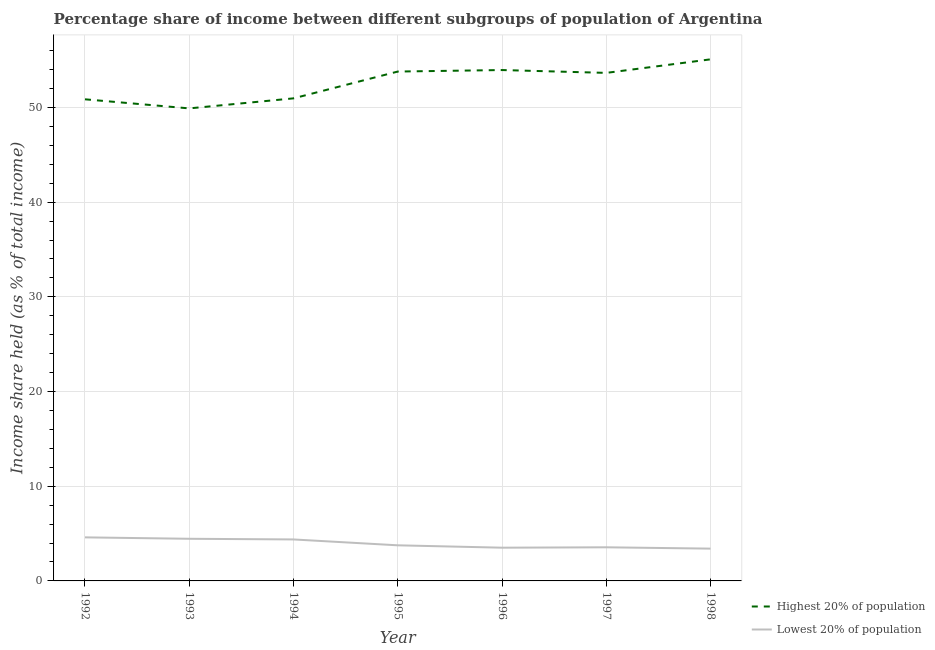What is the income share held by highest 20% of the population in 1997?
Provide a succinct answer. 53.65. Across all years, what is the minimum income share held by lowest 20% of the population?
Provide a succinct answer. 3.41. In which year was the income share held by highest 20% of the population maximum?
Your response must be concise. 1998. In which year was the income share held by lowest 20% of the population minimum?
Provide a succinct answer. 1998. What is the total income share held by lowest 20% of the population in the graph?
Ensure brevity in your answer.  27.66. What is the difference between the income share held by lowest 20% of the population in 1992 and that in 1995?
Ensure brevity in your answer.  0.84. What is the difference between the income share held by highest 20% of the population in 1998 and the income share held by lowest 20% of the population in 1992?
Your answer should be compact. 50.48. What is the average income share held by highest 20% of the population per year?
Your answer should be very brief. 52.6. In the year 1998, what is the difference between the income share held by lowest 20% of the population and income share held by highest 20% of the population?
Ensure brevity in your answer.  -51.67. What is the ratio of the income share held by lowest 20% of the population in 1994 to that in 1997?
Provide a short and direct response. 1.23. Is the income share held by highest 20% of the population in 1995 less than that in 1998?
Your answer should be compact. Yes. Is the difference between the income share held by lowest 20% of the population in 1995 and 1997 greater than the difference between the income share held by highest 20% of the population in 1995 and 1997?
Keep it short and to the point. Yes. What is the difference between the highest and the second highest income share held by lowest 20% of the population?
Your response must be concise. 0.15. What is the difference between the highest and the lowest income share held by lowest 20% of the population?
Offer a terse response. 1.19. In how many years, is the income share held by highest 20% of the population greater than the average income share held by highest 20% of the population taken over all years?
Give a very brief answer. 4. Is the sum of the income share held by lowest 20% of the population in 1994 and 1995 greater than the maximum income share held by highest 20% of the population across all years?
Offer a terse response. No. Is the income share held by highest 20% of the population strictly greater than the income share held by lowest 20% of the population over the years?
Your answer should be compact. Yes. How many lines are there?
Make the answer very short. 2. How many years are there in the graph?
Ensure brevity in your answer.  7. What is the difference between two consecutive major ticks on the Y-axis?
Ensure brevity in your answer.  10. Are the values on the major ticks of Y-axis written in scientific E-notation?
Make the answer very short. No. Does the graph contain any zero values?
Your answer should be compact. No. Does the graph contain grids?
Offer a very short reply. Yes. What is the title of the graph?
Offer a very short reply. Percentage share of income between different subgroups of population of Argentina. What is the label or title of the Y-axis?
Offer a terse response. Income share held (as % of total income). What is the Income share held (as % of total income) of Highest 20% of population in 1992?
Offer a terse response. 50.86. What is the Income share held (as % of total income) of Lowest 20% of population in 1992?
Your answer should be compact. 4.6. What is the Income share held (as % of total income) of Highest 20% of population in 1993?
Your response must be concise. 49.9. What is the Income share held (as % of total income) in Lowest 20% of population in 1993?
Offer a terse response. 4.45. What is the Income share held (as % of total income) of Highest 20% of population in 1994?
Your answer should be very brief. 50.96. What is the Income share held (as % of total income) of Lowest 20% of population in 1994?
Offer a very short reply. 4.38. What is the Income share held (as % of total income) of Highest 20% of population in 1995?
Provide a succinct answer. 53.79. What is the Income share held (as % of total income) of Lowest 20% of population in 1995?
Your answer should be very brief. 3.76. What is the Income share held (as % of total income) in Highest 20% of population in 1996?
Keep it short and to the point. 53.95. What is the Income share held (as % of total income) in Lowest 20% of population in 1996?
Make the answer very short. 3.51. What is the Income share held (as % of total income) in Highest 20% of population in 1997?
Offer a terse response. 53.65. What is the Income share held (as % of total income) in Lowest 20% of population in 1997?
Keep it short and to the point. 3.55. What is the Income share held (as % of total income) in Highest 20% of population in 1998?
Ensure brevity in your answer.  55.08. What is the Income share held (as % of total income) in Lowest 20% of population in 1998?
Your answer should be compact. 3.41. Across all years, what is the maximum Income share held (as % of total income) of Highest 20% of population?
Provide a short and direct response. 55.08. Across all years, what is the minimum Income share held (as % of total income) in Highest 20% of population?
Provide a succinct answer. 49.9. Across all years, what is the minimum Income share held (as % of total income) in Lowest 20% of population?
Make the answer very short. 3.41. What is the total Income share held (as % of total income) in Highest 20% of population in the graph?
Provide a succinct answer. 368.19. What is the total Income share held (as % of total income) in Lowest 20% of population in the graph?
Provide a short and direct response. 27.66. What is the difference between the Income share held (as % of total income) in Lowest 20% of population in 1992 and that in 1994?
Ensure brevity in your answer.  0.22. What is the difference between the Income share held (as % of total income) of Highest 20% of population in 1992 and that in 1995?
Keep it short and to the point. -2.93. What is the difference between the Income share held (as % of total income) of Lowest 20% of population in 1992 and that in 1995?
Give a very brief answer. 0.84. What is the difference between the Income share held (as % of total income) of Highest 20% of population in 1992 and that in 1996?
Your answer should be very brief. -3.09. What is the difference between the Income share held (as % of total income) in Lowest 20% of population in 1992 and that in 1996?
Your answer should be very brief. 1.09. What is the difference between the Income share held (as % of total income) in Highest 20% of population in 1992 and that in 1997?
Provide a short and direct response. -2.79. What is the difference between the Income share held (as % of total income) in Lowest 20% of population in 1992 and that in 1997?
Keep it short and to the point. 1.05. What is the difference between the Income share held (as % of total income) of Highest 20% of population in 1992 and that in 1998?
Provide a succinct answer. -4.22. What is the difference between the Income share held (as % of total income) of Lowest 20% of population in 1992 and that in 1998?
Provide a succinct answer. 1.19. What is the difference between the Income share held (as % of total income) of Highest 20% of population in 1993 and that in 1994?
Provide a short and direct response. -1.06. What is the difference between the Income share held (as % of total income) of Lowest 20% of population in 1993 and that in 1994?
Make the answer very short. 0.07. What is the difference between the Income share held (as % of total income) in Highest 20% of population in 1993 and that in 1995?
Your answer should be very brief. -3.89. What is the difference between the Income share held (as % of total income) in Lowest 20% of population in 1993 and that in 1995?
Your response must be concise. 0.69. What is the difference between the Income share held (as % of total income) in Highest 20% of population in 1993 and that in 1996?
Provide a succinct answer. -4.05. What is the difference between the Income share held (as % of total income) in Highest 20% of population in 1993 and that in 1997?
Keep it short and to the point. -3.75. What is the difference between the Income share held (as % of total income) of Lowest 20% of population in 1993 and that in 1997?
Provide a succinct answer. 0.9. What is the difference between the Income share held (as % of total income) of Highest 20% of population in 1993 and that in 1998?
Your answer should be very brief. -5.18. What is the difference between the Income share held (as % of total income) of Highest 20% of population in 1994 and that in 1995?
Provide a succinct answer. -2.83. What is the difference between the Income share held (as % of total income) of Lowest 20% of population in 1994 and that in 1995?
Provide a short and direct response. 0.62. What is the difference between the Income share held (as % of total income) of Highest 20% of population in 1994 and that in 1996?
Your response must be concise. -2.99. What is the difference between the Income share held (as % of total income) in Lowest 20% of population in 1994 and that in 1996?
Make the answer very short. 0.87. What is the difference between the Income share held (as % of total income) in Highest 20% of population in 1994 and that in 1997?
Give a very brief answer. -2.69. What is the difference between the Income share held (as % of total income) of Lowest 20% of population in 1994 and that in 1997?
Provide a short and direct response. 0.83. What is the difference between the Income share held (as % of total income) in Highest 20% of population in 1994 and that in 1998?
Your answer should be compact. -4.12. What is the difference between the Income share held (as % of total income) in Lowest 20% of population in 1994 and that in 1998?
Give a very brief answer. 0.97. What is the difference between the Income share held (as % of total income) of Highest 20% of population in 1995 and that in 1996?
Make the answer very short. -0.16. What is the difference between the Income share held (as % of total income) in Highest 20% of population in 1995 and that in 1997?
Give a very brief answer. 0.14. What is the difference between the Income share held (as % of total income) of Lowest 20% of population in 1995 and that in 1997?
Provide a short and direct response. 0.21. What is the difference between the Income share held (as % of total income) in Highest 20% of population in 1995 and that in 1998?
Offer a very short reply. -1.29. What is the difference between the Income share held (as % of total income) in Highest 20% of population in 1996 and that in 1997?
Your answer should be very brief. 0.3. What is the difference between the Income share held (as % of total income) in Lowest 20% of population in 1996 and that in 1997?
Your answer should be very brief. -0.04. What is the difference between the Income share held (as % of total income) of Highest 20% of population in 1996 and that in 1998?
Your answer should be compact. -1.13. What is the difference between the Income share held (as % of total income) of Lowest 20% of population in 1996 and that in 1998?
Provide a succinct answer. 0.1. What is the difference between the Income share held (as % of total income) in Highest 20% of population in 1997 and that in 1998?
Make the answer very short. -1.43. What is the difference between the Income share held (as % of total income) of Lowest 20% of population in 1997 and that in 1998?
Your answer should be very brief. 0.14. What is the difference between the Income share held (as % of total income) in Highest 20% of population in 1992 and the Income share held (as % of total income) in Lowest 20% of population in 1993?
Provide a succinct answer. 46.41. What is the difference between the Income share held (as % of total income) in Highest 20% of population in 1992 and the Income share held (as % of total income) in Lowest 20% of population in 1994?
Provide a short and direct response. 46.48. What is the difference between the Income share held (as % of total income) in Highest 20% of population in 1992 and the Income share held (as % of total income) in Lowest 20% of population in 1995?
Ensure brevity in your answer.  47.1. What is the difference between the Income share held (as % of total income) of Highest 20% of population in 1992 and the Income share held (as % of total income) of Lowest 20% of population in 1996?
Your response must be concise. 47.35. What is the difference between the Income share held (as % of total income) in Highest 20% of population in 1992 and the Income share held (as % of total income) in Lowest 20% of population in 1997?
Your response must be concise. 47.31. What is the difference between the Income share held (as % of total income) of Highest 20% of population in 1992 and the Income share held (as % of total income) of Lowest 20% of population in 1998?
Provide a short and direct response. 47.45. What is the difference between the Income share held (as % of total income) in Highest 20% of population in 1993 and the Income share held (as % of total income) in Lowest 20% of population in 1994?
Provide a short and direct response. 45.52. What is the difference between the Income share held (as % of total income) in Highest 20% of population in 1993 and the Income share held (as % of total income) in Lowest 20% of population in 1995?
Give a very brief answer. 46.14. What is the difference between the Income share held (as % of total income) of Highest 20% of population in 1993 and the Income share held (as % of total income) of Lowest 20% of population in 1996?
Your answer should be compact. 46.39. What is the difference between the Income share held (as % of total income) of Highest 20% of population in 1993 and the Income share held (as % of total income) of Lowest 20% of population in 1997?
Offer a terse response. 46.35. What is the difference between the Income share held (as % of total income) of Highest 20% of population in 1993 and the Income share held (as % of total income) of Lowest 20% of population in 1998?
Your answer should be compact. 46.49. What is the difference between the Income share held (as % of total income) in Highest 20% of population in 1994 and the Income share held (as % of total income) in Lowest 20% of population in 1995?
Offer a very short reply. 47.2. What is the difference between the Income share held (as % of total income) in Highest 20% of population in 1994 and the Income share held (as % of total income) in Lowest 20% of population in 1996?
Your response must be concise. 47.45. What is the difference between the Income share held (as % of total income) in Highest 20% of population in 1994 and the Income share held (as % of total income) in Lowest 20% of population in 1997?
Your answer should be compact. 47.41. What is the difference between the Income share held (as % of total income) of Highest 20% of population in 1994 and the Income share held (as % of total income) of Lowest 20% of population in 1998?
Keep it short and to the point. 47.55. What is the difference between the Income share held (as % of total income) of Highest 20% of population in 1995 and the Income share held (as % of total income) of Lowest 20% of population in 1996?
Provide a succinct answer. 50.28. What is the difference between the Income share held (as % of total income) of Highest 20% of population in 1995 and the Income share held (as % of total income) of Lowest 20% of population in 1997?
Ensure brevity in your answer.  50.24. What is the difference between the Income share held (as % of total income) of Highest 20% of population in 1995 and the Income share held (as % of total income) of Lowest 20% of population in 1998?
Ensure brevity in your answer.  50.38. What is the difference between the Income share held (as % of total income) in Highest 20% of population in 1996 and the Income share held (as % of total income) in Lowest 20% of population in 1997?
Your response must be concise. 50.4. What is the difference between the Income share held (as % of total income) in Highest 20% of population in 1996 and the Income share held (as % of total income) in Lowest 20% of population in 1998?
Keep it short and to the point. 50.54. What is the difference between the Income share held (as % of total income) of Highest 20% of population in 1997 and the Income share held (as % of total income) of Lowest 20% of population in 1998?
Your answer should be very brief. 50.24. What is the average Income share held (as % of total income) of Highest 20% of population per year?
Your answer should be very brief. 52.6. What is the average Income share held (as % of total income) in Lowest 20% of population per year?
Your answer should be very brief. 3.95. In the year 1992, what is the difference between the Income share held (as % of total income) of Highest 20% of population and Income share held (as % of total income) of Lowest 20% of population?
Ensure brevity in your answer.  46.26. In the year 1993, what is the difference between the Income share held (as % of total income) in Highest 20% of population and Income share held (as % of total income) in Lowest 20% of population?
Make the answer very short. 45.45. In the year 1994, what is the difference between the Income share held (as % of total income) of Highest 20% of population and Income share held (as % of total income) of Lowest 20% of population?
Make the answer very short. 46.58. In the year 1995, what is the difference between the Income share held (as % of total income) of Highest 20% of population and Income share held (as % of total income) of Lowest 20% of population?
Your response must be concise. 50.03. In the year 1996, what is the difference between the Income share held (as % of total income) of Highest 20% of population and Income share held (as % of total income) of Lowest 20% of population?
Provide a short and direct response. 50.44. In the year 1997, what is the difference between the Income share held (as % of total income) in Highest 20% of population and Income share held (as % of total income) in Lowest 20% of population?
Provide a short and direct response. 50.1. In the year 1998, what is the difference between the Income share held (as % of total income) of Highest 20% of population and Income share held (as % of total income) of Lowest 20% of population?
Provide a succinct answer. 51.67. What is the ratio of the Income share held (as % of total income) in Highest 20% of population in 1992 to that in 1993?
Your answer should be compact. 1.02. What is the ratio of the Income share held (as % of total income) in Lowest 20% of population in 1992 to that in 1993?
Ensure brevity in your answer.  1.03. What is the ratio of the Income share held (as % of total income) of Highest 20% of population in 1992 to that in 1994?
Keep it short and to the point. 1. What is the ratio of the Income share held (as % of total income) in Lowest 20% of population in 1992 to that in 1994?
Ensure brevity in your answer.  1.05. What is the ratio of the Income share held (as % of total income) of Highest 20% of population in 1992 to that in 1995?
Offer a terse response. 0.95. What is the ratio of the Income share held (as % of total income) in Lowest 20% of population in 1992 to that in 1995?
Your answer should be very brief. 1.22. What is the ratio of the Income share held (as % of total income) in Highest 20% of population in 1992 to that in 1996?
Provide a short and direct response. 0.94. What is the ratio of the Income share held (as % of total income) of Lowest 20% of population in 1992 to that in 1996?
Keep it short and to the point. 1.31. What is the ratio of the Income share held (as % of total income) in Highest 20% of population in 1992 to that in 1997?
Offer a terse response. 0.95. What is the ratio of the Income share held (as % of total income) in Lowest 20% of population in 1992 to that in 1997?
Offer a very short reply. 1.3. What is the ratio of the Income share held (as % of total income) in Highest 20% of population in 1992 to that in 1998?
Provide a succinct answer. 0.92. What is the ratio of the Income share held (as % of total income) in Lowest 20% of population in 1992 to that in 1998?
Offer a very short reply. 1.35. What is the ratio of the Income share held (as % of total income) in Highest 20% of population in 1993 to that in 1994?
Your response must be concise. 0.98. What is the ratio of the Income share held (as % of total income) of Highest 20% of population in 1993 to that in 1995?
Your answer should be very brief. 0.93. What is the ratio of the Income share held (as % of total income) of Lowest 20% of population in 1993 to that in 1995?
Your answer should be compact. 1.18. What is the ratio of the Income share held (as % of total income) of Highest 20% of population in 1993 to that in 1996?
Offer a terse response. 0.92. What is the ratio of the Income share held (as % of total income) in Lowest 20% of population in 1993 to that in 1996?
Offer a very short reply. 1.27. What is the ratio of the Income share held (as % of total income) in Highest 20% of population in 1993 to that in 1997?
Offer a very short reply. 0.93. What is the ratio of the Income share held (as % of total income) of Lowest 20% of population in 1993 to that in 1997?
Your answer should be very brief. 1.25. What is the ratio of the Income share held (as % of total income) of Highest 20% of population in 1993 to that in 1998?
Offer a terse response. 0.91. What is the ratio of the Income share held (as % of total income) of Lowest 20% of population in 1993 to that in 1998?
Your answer should be compact. 1.3. What is the ratio of the Income share held (as % of total income) of Lowest 20% of population in 1994 to that in 1995?
Your answer should be compact. 1.16. What is the ratio of the Income share held (as % of total income) in Highest 20% of population in 1994 to that in 1996?
Your answer should be compact. 0.94. What is the ratio of the Income share held (as % of total income) of Lowest 20% of population in 1994 to that in 1996?
Your response must be concise. 1.25. What is the ratio of the Income share held (as % of total income) in Highest 20% of population in 1994 to that in 1997?
Your answer should be very brief. 0.95. What is the ratio of the Income share held (as % of total income) of Lowest 20% of population in 1994 to that in 1997?
Offer a very short reply. 1.23. What is the ratio of the Income share held (as % of total income) of Highest 20% of population in 1994 to that in 1998?
Offer a terse response. 0.93. What is the ratio of the Income share held (as % of total income) in Lowest 20% of population in 1994 to that in 1998?
Make the answer very short. 1.28. What is the ratio of the Income share held (as % of total income) of Lowest 20% of population in 1995 to that in 1996?
Offer a very short reply. 1.07. What is the ratio of the Income share held (as % of total income) of Lowest 20% of population in 1995 to that in 1997?
Provide a short and direct response. 1.06. What is the ratio of the Income share held (as % of total income) of Highest 20% of population in 1995 to that in 1998?
Provide a short and direct response. 0.98. What is the ratio of the Income share held (as % of total income) in Lowest 20% of population in 1995 to that in 1998?
Your answer should be compact. 1.1. What is the ratio of the Income share held (as % of total income) of Highest 20% of population in 1996 to that in 1997?
Your response must be concise. 1.01. What is the ratio of the Income share held (as % of total income) of Lowest 20% of population in 1996 to that in 1997?
Offer a terse response. 0.99. What is the ratio of the Income share held (as % of total income) in Highest 20% of population in 1996 to that in 1998?
Your answer should be very brief. 0.98. What is the ratio of the Income share held (as % of total income) of Lowest 20% of population in 1996 to that in 1998?
Your response must be concise. 1.03. What is the ratio of the Income share held (as % of total income) of Lowest 20% of population in 1997 to that in 1998?
Provide a succinct answer. 1.04. What is the difference between the highest and the second highest Income share held (as % of total income) in Highest 20% of population?
Offer a terse response. 1.13. What is the difference between the highest and the lowest Income share held (as % of total income) in Highest 20% of population?
Ensure brevity in your answer.  5.18. What is the difference between the highest and the lowest Income share held (as % of total income) in Lowest 20% of population?
Make the answer very short. 1.19. 